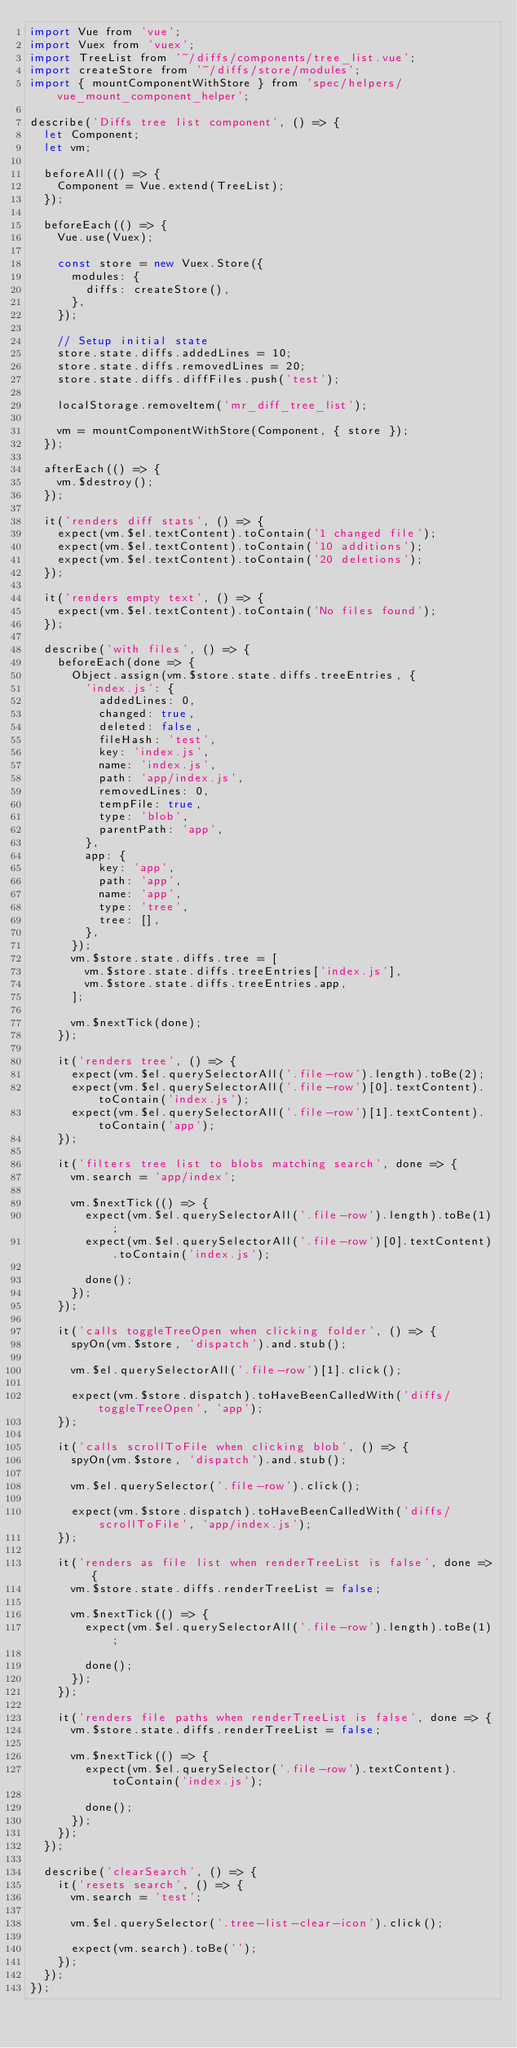Convert code to text. <code><loc_0><loc_0><loc_500><loc_500><_JavaScript_>import Vue from 'vue';
import Vuex from 'vuex';
import TreeList from '~/diffs/components/tree_list.vue';
import createStore from '~/diffs/store/modules';
import { mountComponentWithStore } from 'spec/helpers/vue_mount_component_helper';

describe('Diffs tree list component', () => {
  let Component;
  let vm;

  beforeAll(() => {
    Component = Vue.extend(TreeList);
  });

  beforeEach(() => {
    Vue.use(Vuex);

    const store = new Vuex.Store({
      modules: {
        diffs: createStore(),
      },
    });

    // Setup initial state
    store.state.diffs.addedLines = 10;
    store.state.diffs.removedLines = 20;
    store.state.diffs.diffFiles.push('test');

    localStorage.removeItem('mr_diff_tree_list');

    vm = mountComponentWithStore(Component, { store });
  });

  afterEach(() => {
    vm.$destroy();
  });

  it('renders diff stats', () => {
    expect(vm.$el.textContent).toContain('1 changed file');
    expect(vm.$el.textContent).toContain('10 additions');
    expect(vm.$el.textContent).toContain('20 deletions');
  });

  it('renders empty text', () => {
    expect(vm.$el.textContent).toContain('No files found');
  });

  describe('with files', () => {
    beforeEach(done => {
      Object.assign(vm.$store.state.diffs.treeEntries, {
        'index.js': {
          addedLines: 0,
          changed: true,
          deleted: false,
          fileHash: 'test',
          key: 'index.js',
          name: 'index.js',
          path: 'app/index.js',
          removedLines: 0,
          tempFile: true,
          type: 'blob',
          parentPath: 'app',
        },
        app: {
          key: 'app',
          path: 'app',
          name: 'app',
          type: 'tree',
          tree: [],
        },
      });
      vm.$store.state.diffs.tree = [
        vm.$store.state.diffs.treeEntries['index.js'],
        vm.$store.state.diffs.treeEntries.app,
      ];

      vm.$nextTick(done);
    });

    it('renders tree', () => {
      expect(vm.$el.querySelectorAll('.file-row').length).toBe(2);
      expect(vm.$el.querySelectorAll('.file-row')[0].textContent).toContain('index.js');
      expect(vm.$el.querySelectorAll('.file-row')[1].textContent).toContain('app');
    });

    it('filters tree list to blobs matching search', done => {
      vm.search = 'app/index';

      vm.$nextTick(() => {
        expect(vm.$el.querySelectorAll('.file-row').length).toBe(1);
        expect(vm.$el.querySelectorAll('.file-row')[0].textContent).toContain('index.js');

        done();
      });
    });

    it('calls toggleTreeOpen when clicking folder', () => {
      spyOn(vm.$store, 'dispatch').and.stub();

      vm.$el.querySelectorAll('.file-row')[1].click();

      expect(vm.$store.dispatch).toHaveBeenCalledWith('diffs/toggleTreeOpen', 'app');
    });

    it('calls scrollToFile when clicking blob', () => {
      spyOn(vm.$store, 'dispatch').and.stub();

      vm.$el.querySelector('.file-row').click();

      expect(vm.$store.dispatch).toHaveBeenCalledWith('diffs/scrollToFile', 'app/index.js');
    });

    it('renders as file list when renderTreeList is false', done => {
      vm.$store.state.diffs.renderTreeList = false;

      vm.$nextTick(() => {
        expect(vm.$el.querySelectorAll('.file-row').length).toBe(1);

        done();
      });
    });

    it('renders file paths when renderTreeList is false', done => {
      vm.$store.state.diffs.renderTreeList = false;

      vm.$nextTick(() => {
        expect(vm.$el.querySelector('.file-row').textContent).toContain('index.js');

        done();
      });
    });
  });

  describe('clearSearch', () => {
    it('resets search', () => {
      vm.search = 'test';

      vm.$el.querySelector('.tree-list-clear-icon').click();

      expect(vm.search).toBe('');
    });
  });
});
</code> 